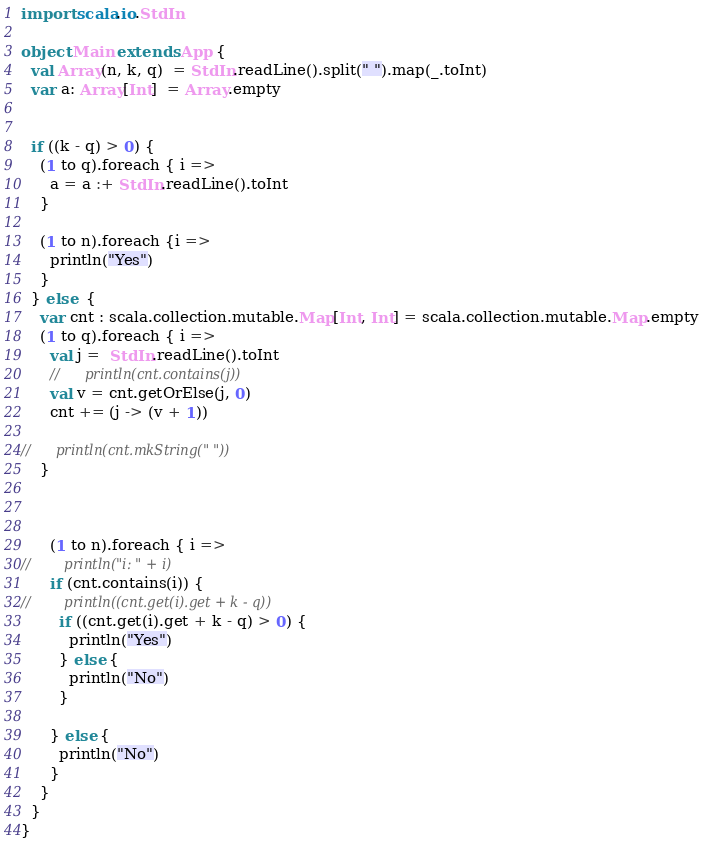<code> <loc_0><loc_0><loc_500><loc_500><_Scala_>import scala.io.StdIn

object Main extends App {
  val Array(n, k, q)  = StdIn.readLine().split(" ").map(_.toInt)
  var a: Array[Int]  = Array.empty


  if ((k - q) > 0) {
    (1 to q).foreach { i =>
      a = a :+ StdIn.readLine().toInt
    }
    
    (1 to n).foreach {i =>
      println("Yes")
    }
  } else  {
    var cnt : scala.collection.mutable.Map[Int, Int] = scala.collection.mutable.Map.empty
    (1 to q).foreach { i =>
      val j =  StdIn.readLine().toInt
      //      println(cnt.contains(j))
      val v = cnt.getOrElse(j, 0)
      cnt += (j -> (v + 1))

//      println(cnt.mkString(" "))
    }



      (1 to n).foreach { i =>
//        println("i: " + i)
      if (cnt.contains(i)) {
//        println((cnt.get(i).get + k - q))
        if ((cnt.get(i).get + k - q) > 0) {
          println("Yes")
        } else {
          println("No")
        }

      } else {
        println("No")        
      }
    }
  }
}
</code> 